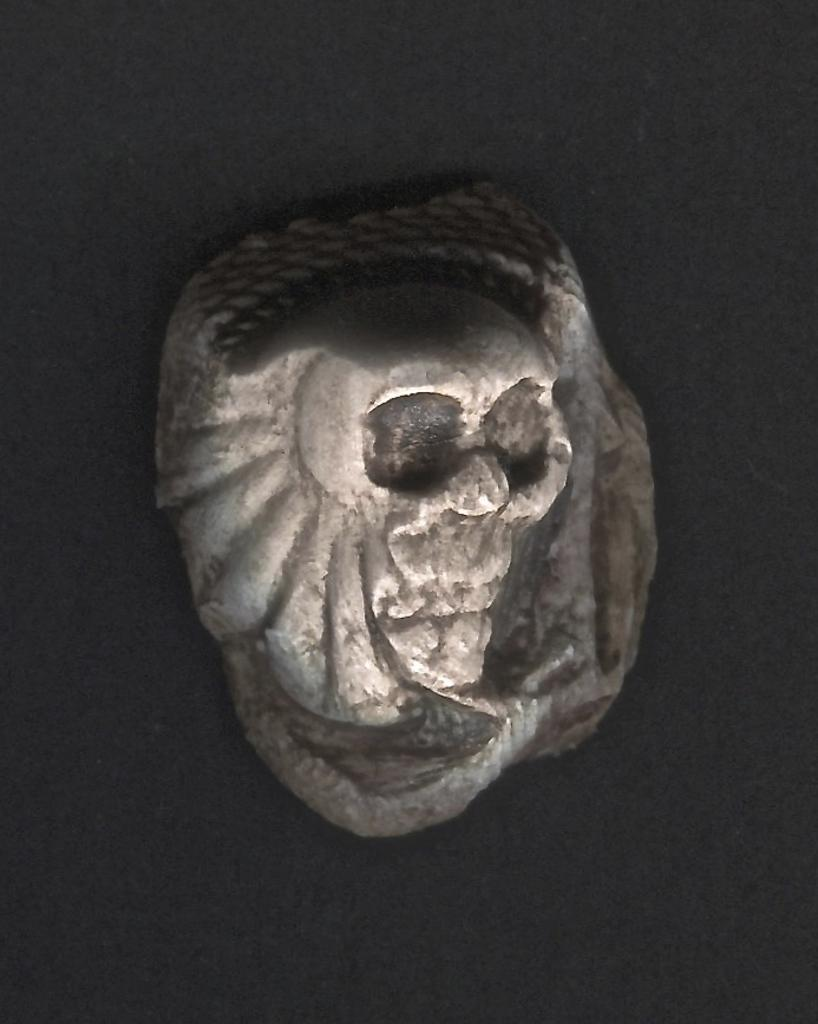What is the main subject of the image? There is a sculpture in the image. How many passengers are visible in the image? There are no passengers present in the image, as it features a sculpture. What type of flock can be seen flying in the image? There is no flock present in the image, as it features a sculpture. 